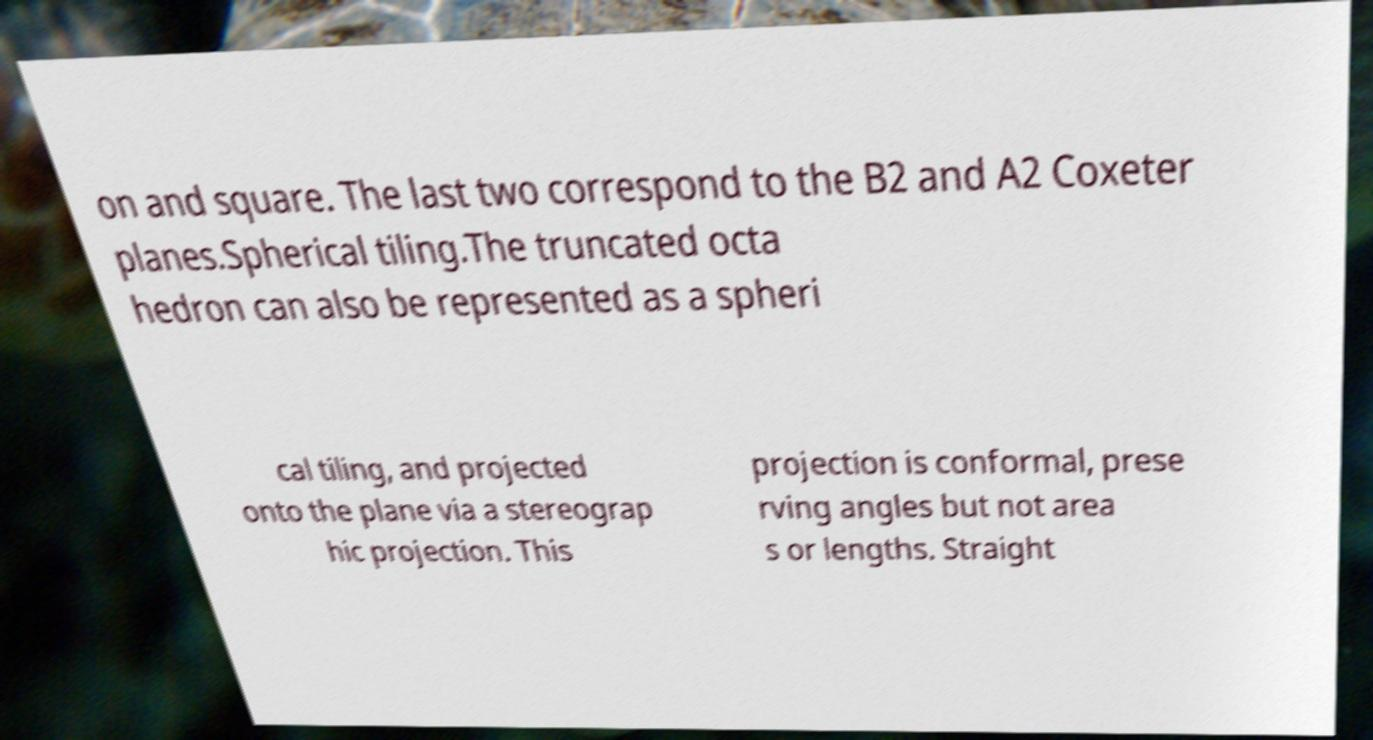Could you assist in decoding the text presented in this image and type it out clearly? on and square. The last two correspond to the B2 and A2 Coxeter planes.Spherical tiling.The truncated octa hedron can also be represented as a spheri cal tiling, and projected onto the plane via a stereograp hic projection. This projection is conformal, prese rving angles but not area s or lengths. Straight 